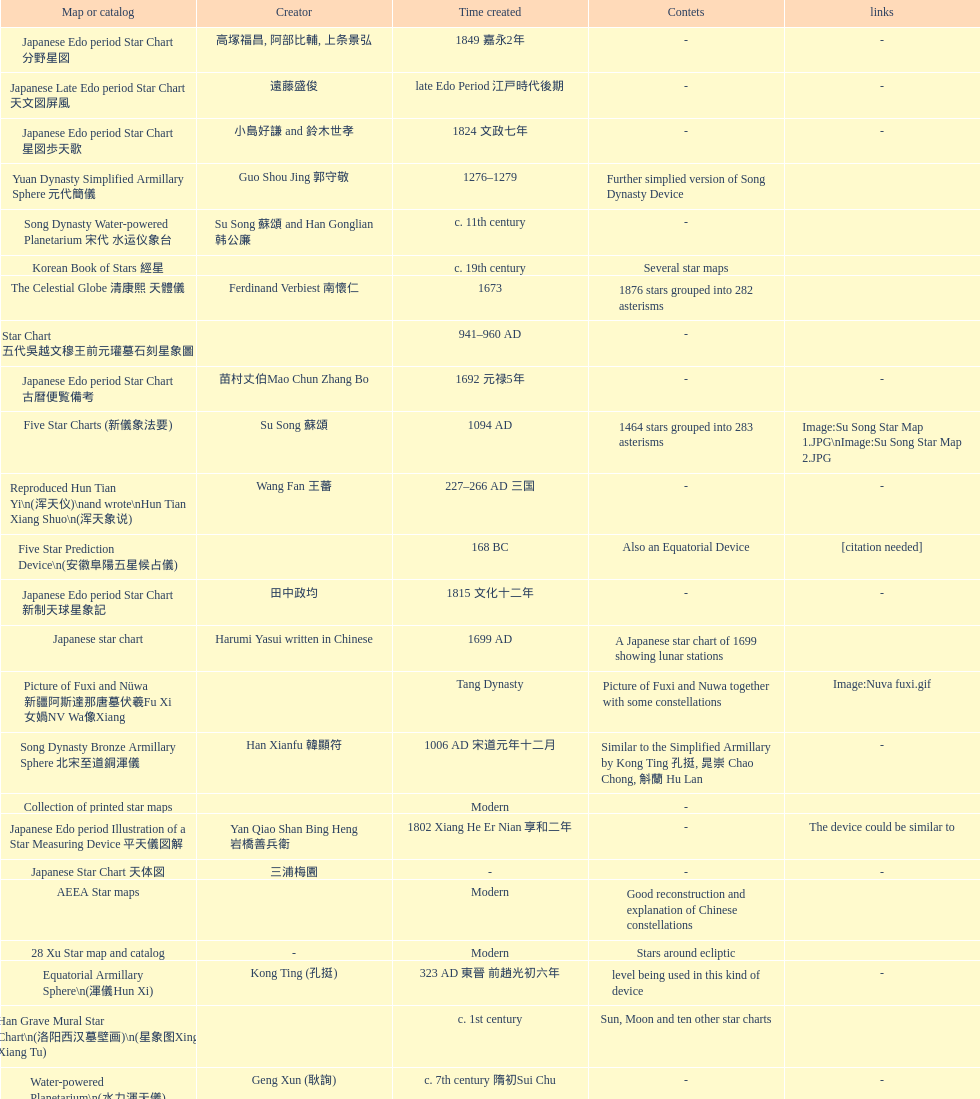Name three items created not long after the equatorial armillary sphere. Celestial Globe (渾象) (圓儀), First remark of a constellation in observation in Korean history, First Ecliptic Armillary Sphere (黄道仪Huang Dao Yi). 